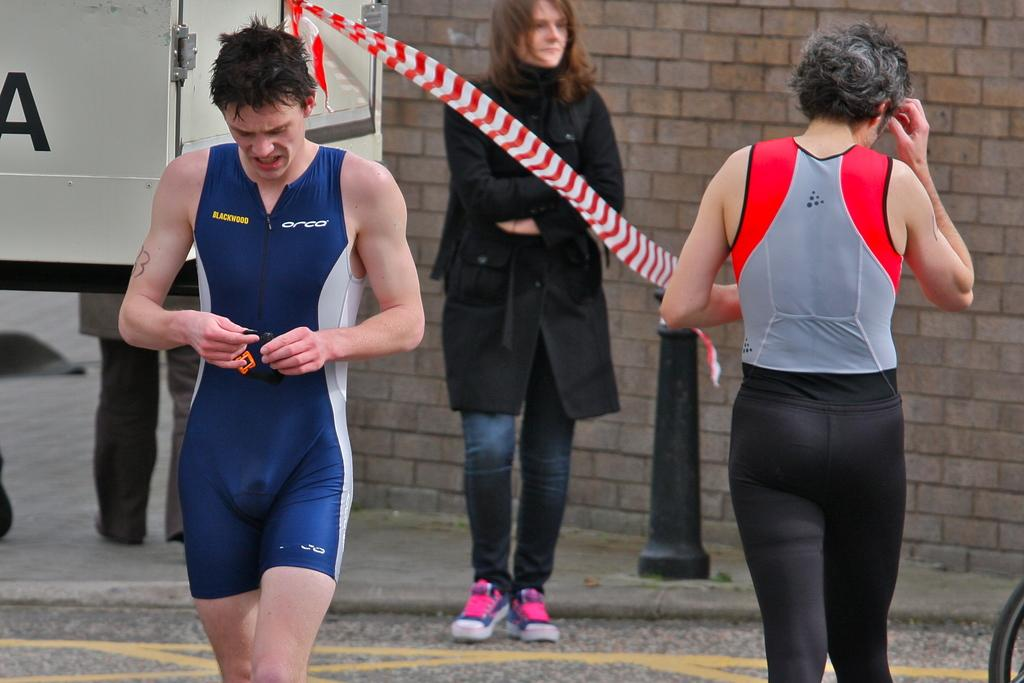<image>
Create a compact narrative representing the image presented. A man walks towards the camera, his shirt has the word ORCA on it. 